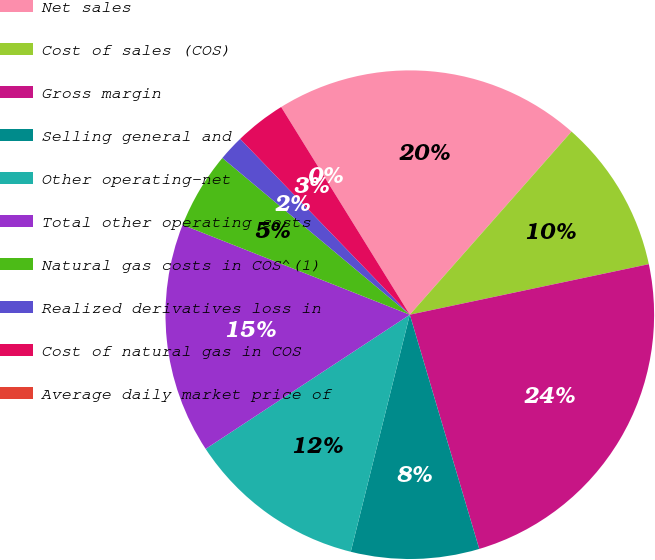Convert chart. <chart><loc_0><loc_0><loc_500><loc_500><pie_chart><fcel>Net sales<fcel>Cost of sales (COS)<fcel>Gross margin<fcel>Selling general and<fcel>Other operating-net<fcel>Total other operating costs<fcel>Natural gas costs in COS^(1)<fcel>Realized derivatives loss in<fcel>Cost of natural gas in COS<fcel>Average daily market price of<nl><fcel>20.34%<fcel>10.17%<fcel>23.73%<fcel>8.47%<fcel>11.86%<fcel>15.25%<fcel>5.09%<fcel>1.7%<fcel>3.39%<fcel>0.0%<nl></chart> 